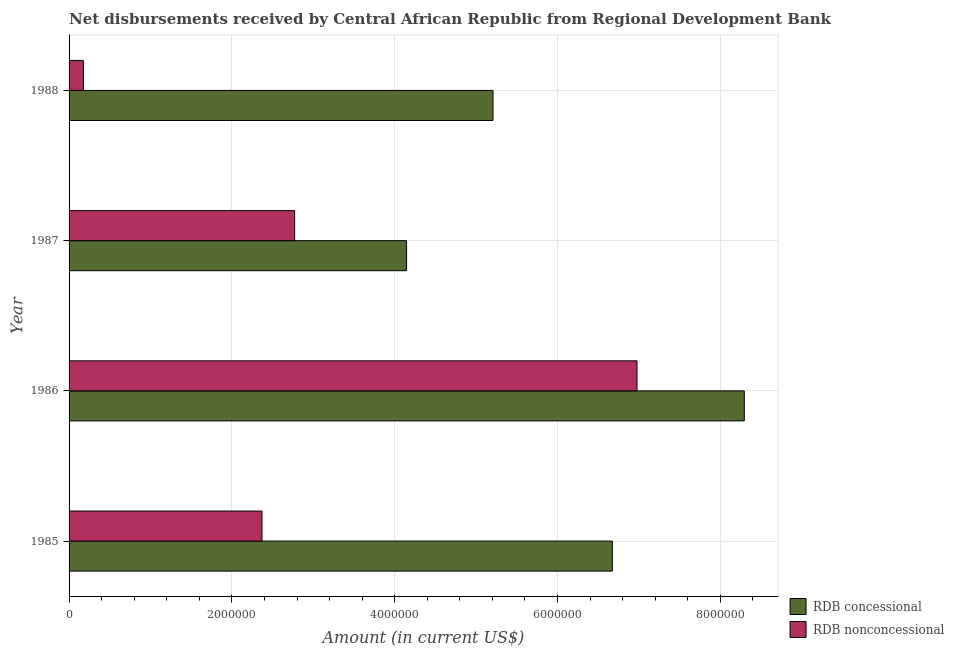How many bars are there on the 3rd tick from the top?
Your answer should be compact. 2. What is the net non concessional disbursements from rdb in 1986?
Give a very brief answer. 6.98e+06. Across all years, what is the maximum net concessional disbursements from rdb?
Provide a short and direct response. 8.30e+06. Across all years, what is the minimum net non concessional disbursements from rdb?
Your response must be concise. 1.76e+05. In which year was the net non concessional disbursements from rdb maximum?
Provide a short and direct response. 1986. What is the total net concessional disbursements from rdb in the graph?
Your answer should be very brief. 2.43e+07. What is the difference between the net non concessional disbursements from rdb in 1987 and that in 1988?
Offer a terse response. 2.60e+06. What is the difference between the net non concessional disbursements from rdb in 1987 and the net concessional disbursements from rdb in 1986?
Provide a short and direct response. -5.52e+06. What is the average net concessional disbursements from rdb per year?
Your answer should be very brief. 6.08e+06. In the year 1988, what is the difference between the net non concessional disbursements from rdb and net concessional disbursements from rdb?
Your answer should be very brief. -5.03e+06. In how many years, is the net non concessional disbursements from rdb greater than 4800000 US$?
Your answer should be compact. 1. What is the ratio of the net concessional disbursements from rdb in 1987 to that in 1988?
Keep it short and to the point. 0.8. Is the net non concessional disbursements from rdb in 1986 less than that in 1988?
Your answer should be compact. No. Is the difference between the net non concessional disbursements from rdb in 1985 and 1986 greater than the difference between the net concessional disbursements from rdb in 1985 and 1986?
Ensure brevity in your answer.  No. What is the difference between the highest and the second highest net non concessional disbursements from rdb?
Keep it short and to the point. 4.21e+06. What is the difference between the highest and the lowest net concessional disbursements from rdb?
Give a very brief answer. 4.15e+06. In how many years, is the net non concessional disbursements from rdb greater than the average net non concessional disbursements from rdb taken over all years?
Provide a succinct answer. 1. Is the sum of the net concessional disbursements from rdb in 1986 and 1988 greater than the maximum net non concessional disbursements from rdb across all years?
Your answer should be compact. Yes. What does the 2nd bar from the top in 1988 represents?
Provide a succinct answer. RDB concessional. What does the 1st bar from the bottom in 1987 represents?
Make the answer very short. RDB concessional. How many bars are there?
Provide a succinct answer. 8. How many years are there in the graph?
Your answer should be very brief. 4. What is the difference between two consecutive major ticks on the X-axis?
Provide a short and direct response. 2.00e+06. Does the graph contain any zero values?
Provide a short and direct response. No. Where does the legend appear in the graph?
Offer a very short reply. Bottom right. How many legend labels are there?
Give a very brief answer. 2. How are the legend labels stacked?
Provide a succinct answer. Vertical. What is the title of the graph?
Make the answer very short. Net disbursements received by Central African Republic from Regional Development Bank. Does "Current education expenditure" appear as one of the legend labels in the graph?
Ensure brevity in your answer.  No. What is the label or title of the Y-axis?
Offer a terse response. Year. What is the Amount (in current US$) of RDB concessional in 1985?
Give a very brief answer. 6.67e+06. What is the Amount (in current US$) of RDB nonconcessional in 1985?
Provide a succinct answer. 2.37e+06. What is the Amount (in current US$) of RDB concessional in 1986?
Your response must be concise. 8.30e+06. What is the Amount (in current US$) in RDB nonconcessional in 1986?
Provide a short and direct response. 6.98e+06. What is the Amount (in current US$) in RDB concessional in 1987?
Offer a terse response. 4.15e+06. What is the Amount (in current US$) of RDB nonconcessional in 1987?
Keep it short and to the point. 2.77e+06. What is the Amount (in current US$) in RDB concessional in 1988?
Give a very brief answer. 5.21e+06. What is the Amount (in current US$) in RDB nonconcessional in 1988?
Provide a short and direct response. 1.76e+05. Across all years, what is the maximum Amount (in current US$) of RDB concessional?
Provide a succinct answer. 8.30e+06. Across all years, what is the maximum Amount (in current US$) of RDB nonconcessional?
Give a very brief answer. 6.98e+06. Across all years, what is the minimum Amount (in current US$) of RDB concessional?
Make the answer very short. 4.15e+06. Across all years, what is the minimum Amount (in current US$) of RDB nonconcessional?
Give a very brief answer. 1.76e+05. What is the total Amount (in current US$) of RDB concessional in the graph?
Your answer should be very brief. 2.43e+07. What is the total Amount (in current US$) of RDB nonconcessional in the graph?
Your answer should be compact. 1.23e+07. What is the difference between the Amount (in current US$) in RDB concessional in 1985 and that in 1986?
Ensure brevity in your answer.  -1.62e+06. What is the difference between the Amount (in current US$) in RDB nonconcessional in 1985 and that in 1986?
Provide a short and direct response. -4.61e+06. What is the difference between the Amount (in current US$) of RDB concessional in 1985 and that in 1987?
Offer a terse response. 2.53e+06. What is the difference between the Amount (in current US$) of RDB nonconcessional in 1985 and that in 1987?
Your answer should be compact. -4.01e+05. What is the difference between the Amount (in current US$) in RDB concessional in 1985 and that in 1988?
Provide a succinct answer. 1.47e+06. What is the difference between the Amount (in current US$) of RDB nonconcessional in 1985 and that in 1988?
Your answer should be compact. 2.19e+06. What is the difference between the Amount (in current US$) of RDB concessional in 1986 and that in 1987?
Provide a short and direct response. 4.15e+06. What is the difference between the Amount (in current US$) of RDB nonconcessional in 1986 and that in 1987?
Ensure brevity in your answer.  4.21e+06. What is the difference between the Amount (in current US$) of RDB concessional in 1986 and that in 1988?
Provide a short and direct response. 3.09e+06. What is the difference between the Amount (in current US$) of RDB nonconcessional in 1986 and that in 1988?
Your answer should be compact. 6.80e+06. What is the difference between the Amount (in current US$) in RDB concessional in 1987 and that in 1988?
Offer a very short reply. -1.06e+06. What is the difference between the Amount (in current US$) in RDB nonconcessional in 1987 and that in 1988?
Your answer should be very brief. 2.60e+06. What is the difference between the Amount (in current US$) of RDB concessional in 1985 and the Amount (in current US$) of RDB nonconcessional in 1986?
Make the answer very short. -3.03e+05. What is the difference between the Amount (in current US$) of RDB concessional in 1985 and the Amount (in current US$) of RDB nonconcessional in 1987?
Provide a short and direct response. 3.90e+06. What is the difference between the Amount (in current US$) of RDB concessional in 1985 and the Amount (in current US$) of RDB nonconcessional in 1988?
Offer a terse response. 6.50e+06. What is the difference between the Amount (in current US$) of RDB concessional in 1986 and the Amount (in current US$) of RDB nonconcessional in 1987?
Your answer should be very brief. 5.52e+06. What is the difference between the Amount (in current US$) in RDB concessional in 1986 and the Amount (in current US$) in RDB nonconcessional in 1988?
Your response must be concise. 8.12e+06. What is the difference between the Amount (in current US$) in RDB concessional in 1987 and the Amount (in current US$) in RDB nonconcessional in 1988?
Give a very brief answer. 3.97e+06. What is the average Amount (in current US$) in RDB concessional per year?
Your answer should be compact. 6.08e+06. What is the average Amount (in current US$) of RDB nonconcessional per year?
Provide a succinct answer. 3.07e+06. In the year 1985, what is the difference between the Amount (in current US$) in RDB concessional and Amount (in current US$) in RDB nonconcessional?
Give a very brief answer. 4.30e+06. In the year 1986, what is the difference between the Amount (in current US$) in RDB concessional and Amount (in current US$) in RDB nonconcessional?
Offer a very short reply. 1.32e+06. In the year 1987, what is the difference between the Amount (in current US$) of RDB concessional and Amount (in current US$) of RDB nonconcessional?
Ensure brevity in your answer.  1.38e+06. In the year 1988, what is the difference between the Amount (in current US$) of RDB concessional and Amount (in current US$) of RDB nonconcessional?
Give a very brief answer. 5.03e+06. What is the ratio of the Amount (in current US$) in RDB concessional in 1985 to that in 1986?
Your response must be concise. 0.8. What is the ratio of the Amount (in current US$) of RDB nonconcessional in 1985 to that in 1986?
Offer a terse response. 0.34. What is the ratio of the Amount (in current US$) of RDB concessional in 1985 to that in 1987?
Give a very brief answer. 1.61. What is the ratio of the Amount (in current US$) in RDB nonconcessional in 1985 to that in 1987?
Offer a terse response. 0.86. What is the ratio of the Amount (in current US$) of RDB concessional in 1985 to that in 1988?
Give a very brief answer. 1.28. What is the ratio of the Amount (in current US$) of RDB nonconcessional in 1985 to that in 1988?
Your answer should be very brief. 13.47. What is the ratio of the Amount (in current US$) of RDB concessional in 1986 to that in 1987?
Make the answer very short. 2. What is the ratio of the Amount (in current US$) in RDB nonconcessional in 1986 to that in 1987?
Give a very brief answer. 2.52. What is the ratio of the Amount (in current US$) of RDB concessional in 1986 to that in 1988?
Keep it short and to the point. 1.59. What is the ratio of the Amount (in current US$) in RDB nonconcessional in 1986 to that in 1988?
Give a very brief answer. 39.64. What is the ratio of the Amount (in current US$) of RDB concessional in 1987 to that in 1988?
Your answer should be compact. 0.8. What is the ratio of the Amount (in current US$) of RDB nonconcessional in 1987 to that in 1988?
Your response must be concise. 15.74. What is the difference between the highest and the second highest Amount (in current US$) in RDB concessional?
Provide a succinct answer. 1.62e+06. What is the difference between the highest and the second highest Amount (in current US$) of RDB nonconcessional?
Ensure brevity in your answer.  4.21e+06. What is the difference between the highest and the lowest Amount (in current US$) of RDB concessional?
Make the answer very short. 4.15e+06. What is the difference between the highest and the lowest Amount (in current US$) of RDB nonconcessional?
Give a very brief answer. 6.80e+06. 